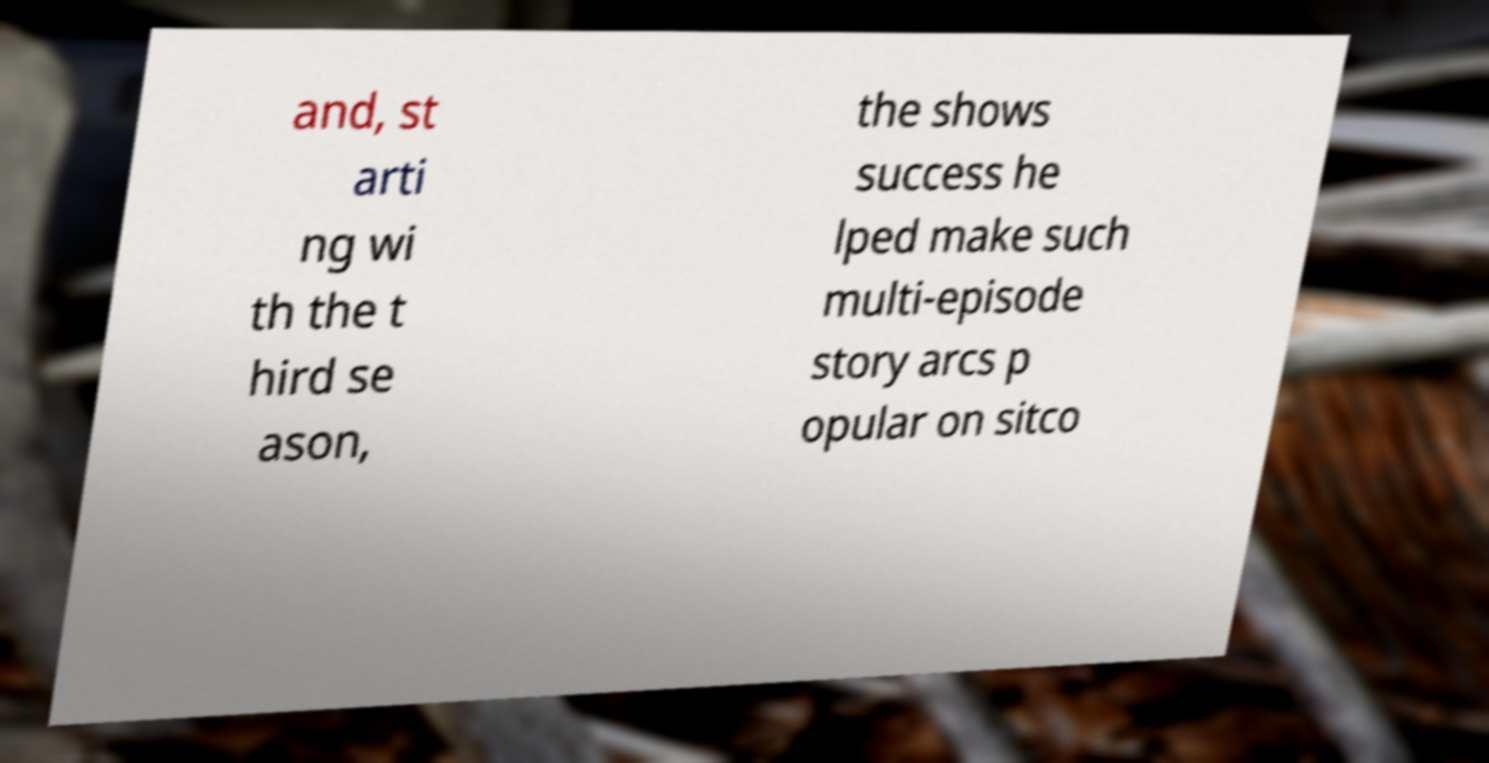Can you accurately transcribe the text from the provided image for me? and, st arti ng wi th the t hird se ason, the shows success he lped make such multi-episode story arcs p opular on sitco 